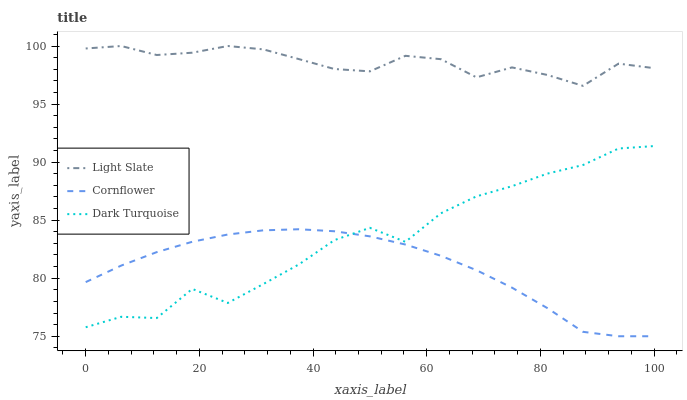Does Cornflower have the minimum area under the curve?
Answer yes or no. Yes. Does Light Slate have the maximum area under the curve?
Answer yes or no. Yes. Does Dark Turquoise have the minimum area under the curve?
Answer yes or no. No. Does Dark Turquoise have the maximum area under the curve?
Answer yes or no. No. Is Cornflower the smoothest?
Answer yes or no. Yes. Is Dark Turquoise the roughest?
Answer yes or no. Yes. Is Dark Turquoise the smoothest?
Answer yes or no. No. Is Cornflower the roughest?
Answer yes or no. No. Does Cornflower have the lowest value?
Answer yes or no. Yes. Does Dark Turquoise have the lowest value?
Answer yes or no. No. Does Light Slate have the highest value?
Answer yes or no. Yes. Does Dark Turquoise have the highest value?
Answer yes or no. No. Is Cornflower less than Light Slate?
Answer yes or no. Yes. Is Light Slate greater than Dark Turquoise?
Answer yes or no. Yes. Does Cornflower intersect Dark Turquoise?
Answer yes or no. Yes. Is Cornflower less than Dark Turquoise?
Answer yes or no. No. Is Cornflower greater than Dark Turquoise?
Answer yes or no. No. Does Cornflower intersect Light Slate?
Answer yes or no. No. 